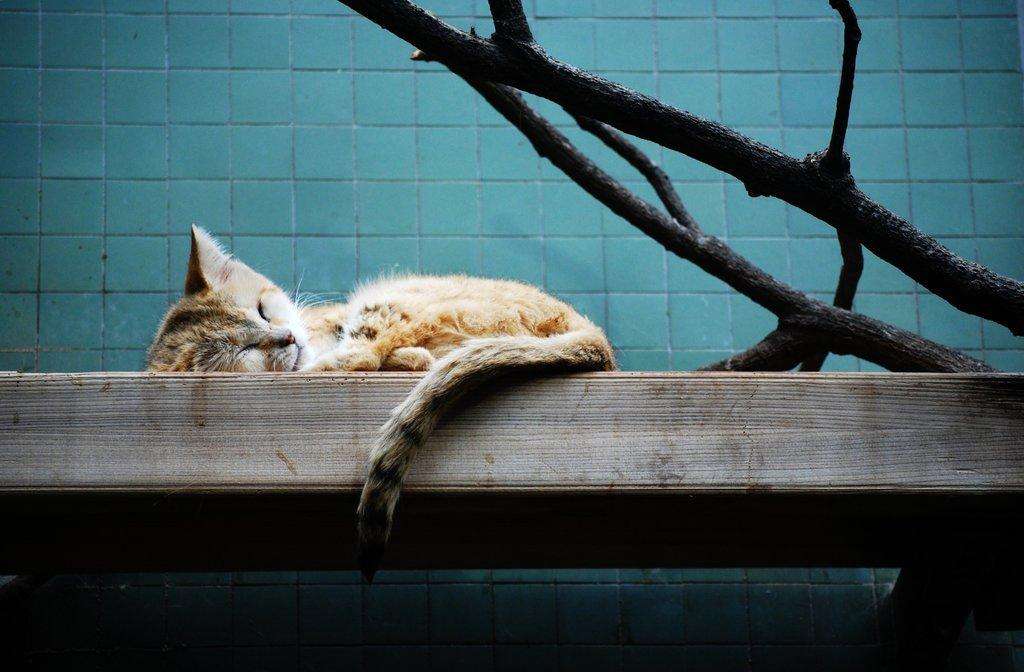What type of material is the main object in the image made of? The main object in the image is made of wood. What animal can be seen on the wooden object? A cat is present on the wooden object. What else is visible in the image besides the wooden object and the cat? There are stems visible in the image. What can be seen in the background of the image? There is a wall in the background of the image. How many goldfish are swimming in the image? There are no goldfish present in the image. What time of day is it in the image, based on the cat's hour? The image does not provide any information about the cat's hour or the time of day. 